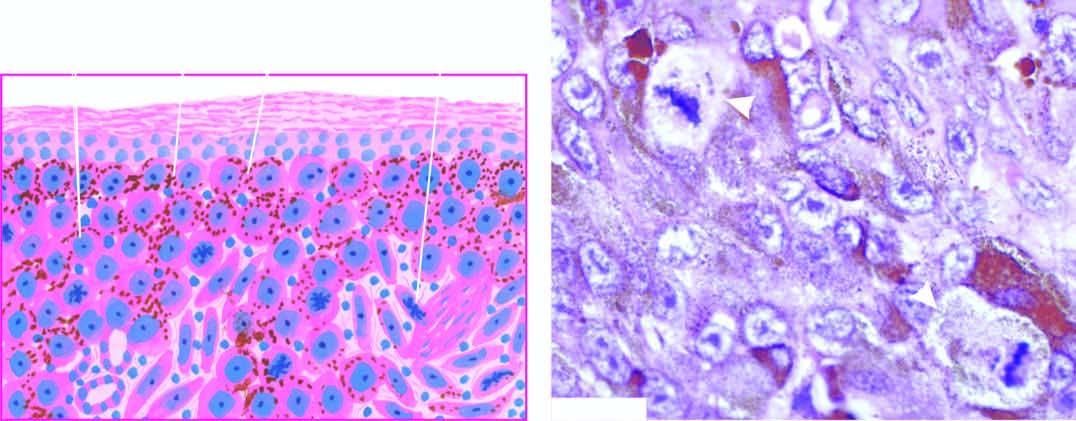re the lesions seen as solid masses in the dermis?
Answer the question using a single word or phrase. No 